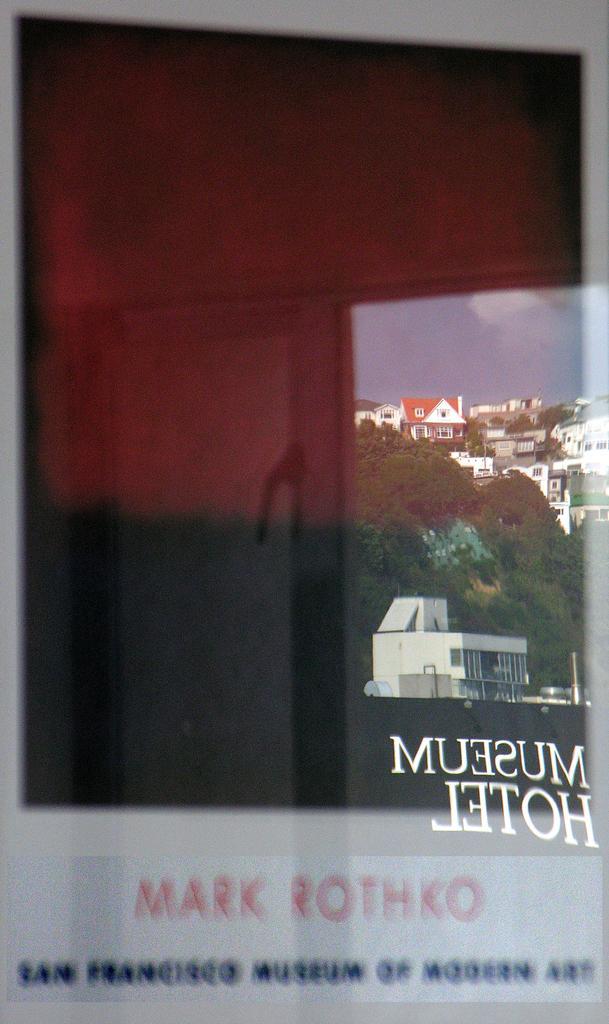In one or two sentences, can you explain what this image depicts? In this image there is glass, on that glass there are houses,trees and a sky are reflecting. 